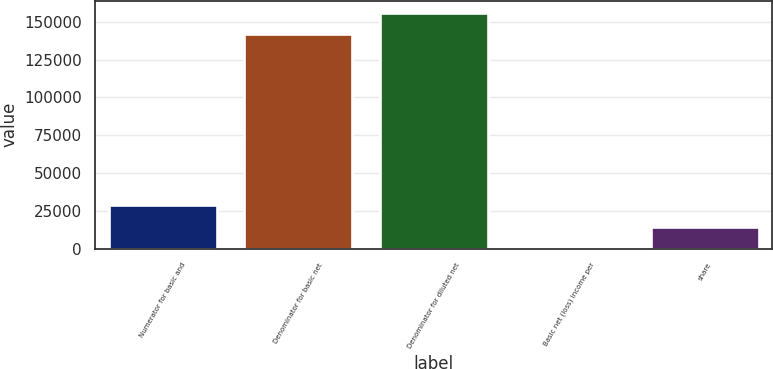Convert chart. <chart><loc_0><loc_0><loc_500><loc_500><bar_chart><fcel>Numerator for basic and<fcel>Denominator for basic net<fcel>Denominator for diluted net<fcel>Basic net (loss) income per<fcel>share<nl><fcel>28845<fcel>141937<fcel>156131<fcel>0.2<fcel>14193.9<nl></chart> 